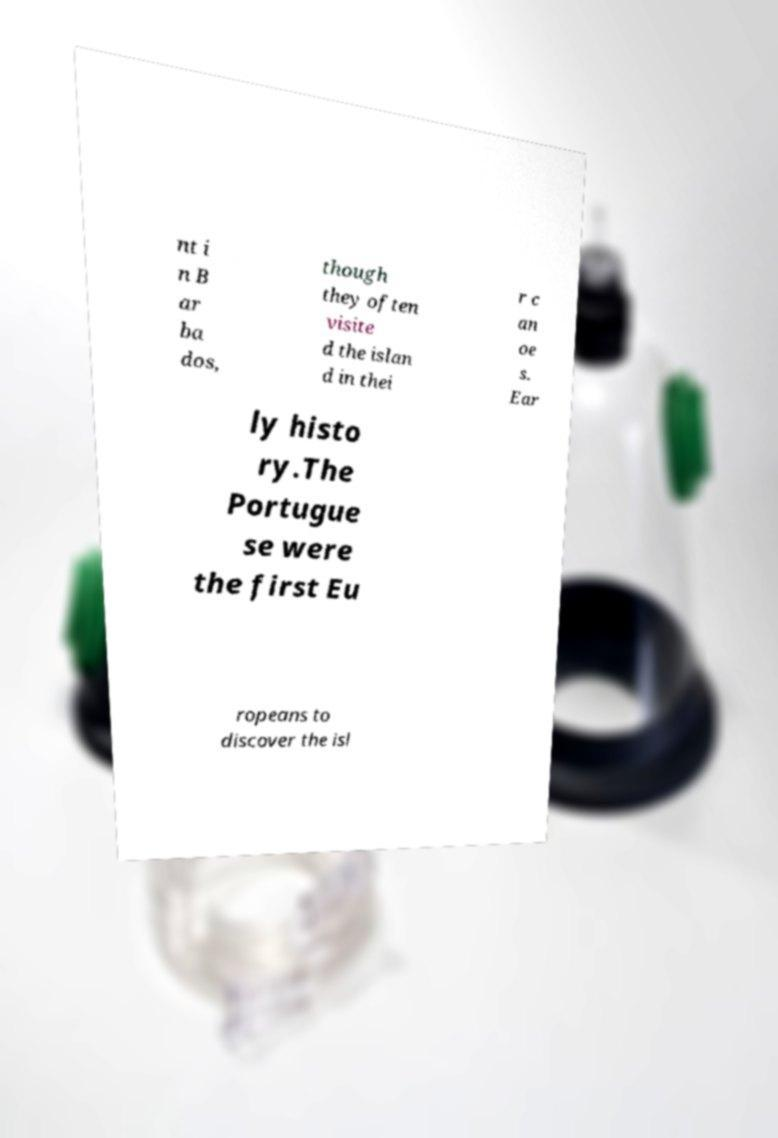Can you read and provide the text displayed in the image?This photo seems to have some interesting text. Can you extract and type it out for me? nt i n B ar ba dos, though they often visite d the islan d in thei r c an oe s. Ear ly histo ry.The Portugue se were the first Eu ropeans to discover the isl 